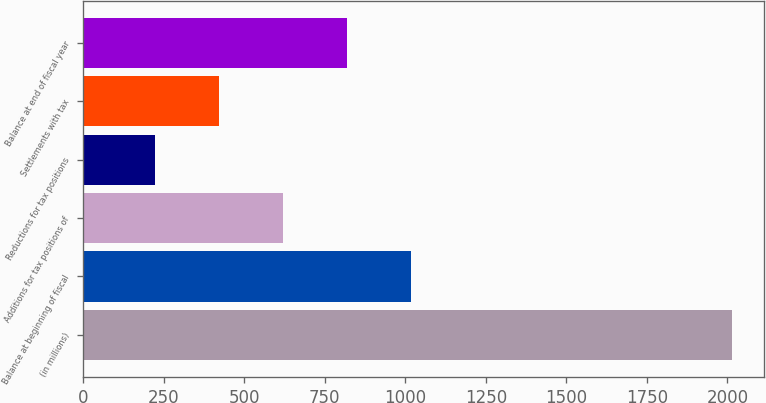Convert chart. <chart><loc_0><loc_0><loc_500><loc_500><bar_chart><fcel>(in millions)<fcel>Balance at beginning of fiscal<fcel>Additions for tax positions of<fcel>Reductions for tax positions<fcel>Settlements with tax<fcel>Balance at end of fiscal year<nl><fcel>2013<fcel>1017.5<fcel>619.3<fcel>221.1<fcel>420.2<fcel>818.4<nl></chart> 